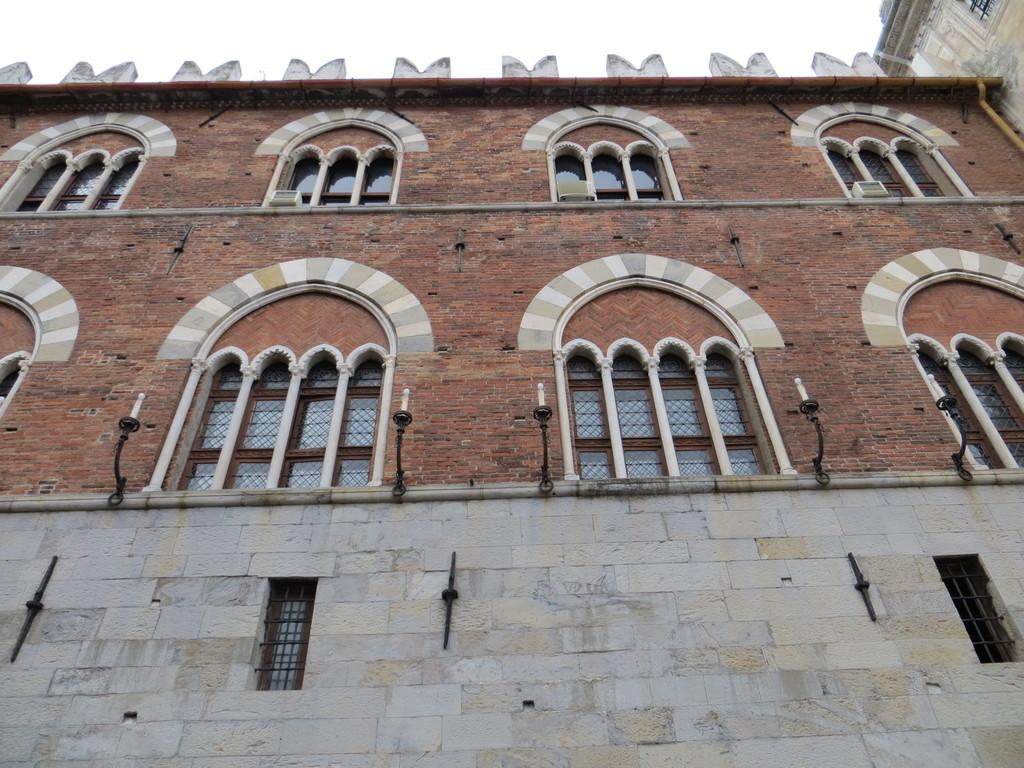What type of structure is visible in the image? There is a building in the image. What objects can be seen inside the building? There are candles visible in the image. What architectural feature is present in the building? There are windows in the image. What is visible at the top of the image? The sky is visible at the top of the image. Where is the plantation located in the image? There is no plantation present in the image. Can you describe the coach that is parked outside the building? There is no coach present in the image. 